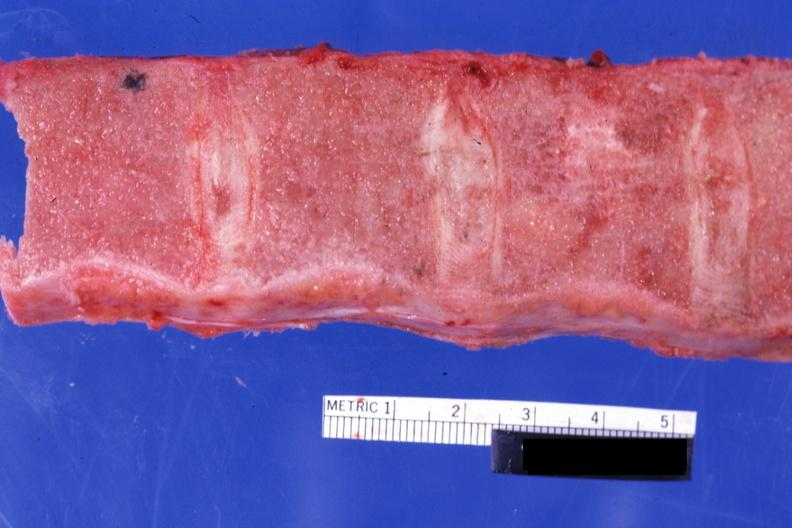does bone, calvarium show sectioned vertebrae with no red marrow case of chronic myelogenous leukemia in blast crisis?
Answer the question using a single word or phrase. No 